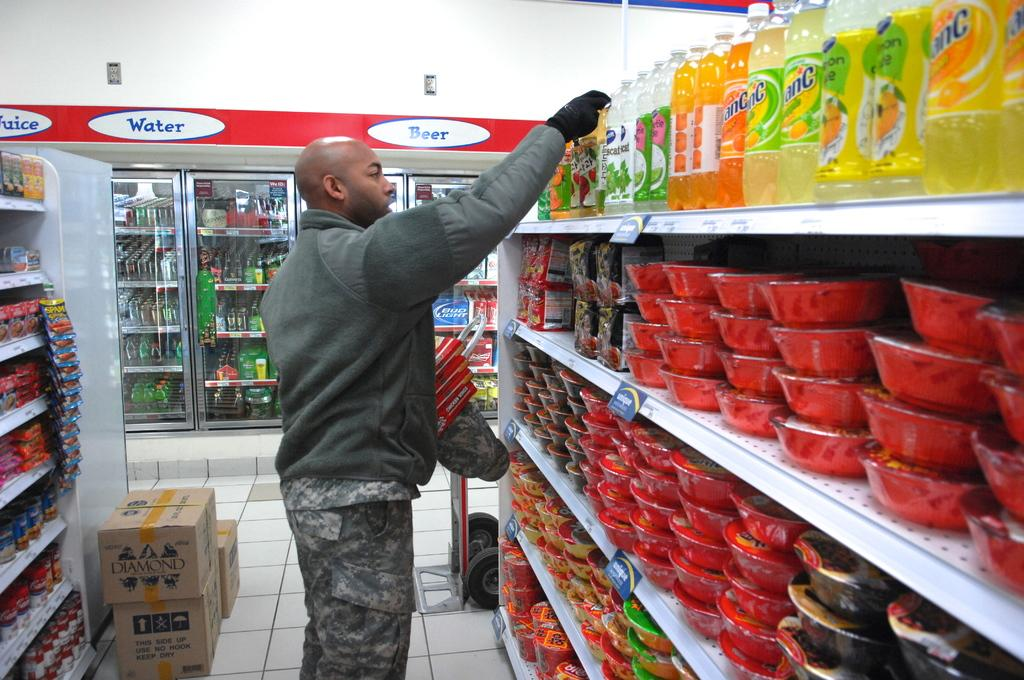<image>
Create a compact narrative representing the image presented. A man is picking items off the grocery store shelf's near the beer section. 